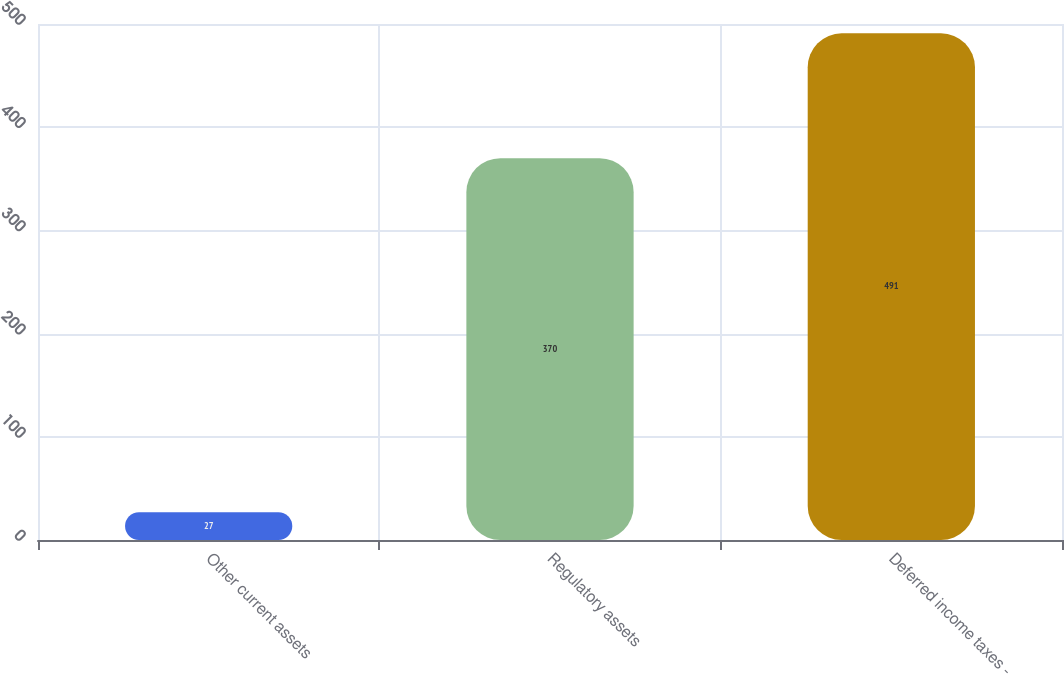Convert chart. <chart><loc_0><loc_0><loc_500><loc_500><bar_chart><fcel>Other current assets<fcel>Regulatory assets<fcel>Deferred income taxes -<nl><fcel>27<fcel>370<fcel>491<nl></chart> 